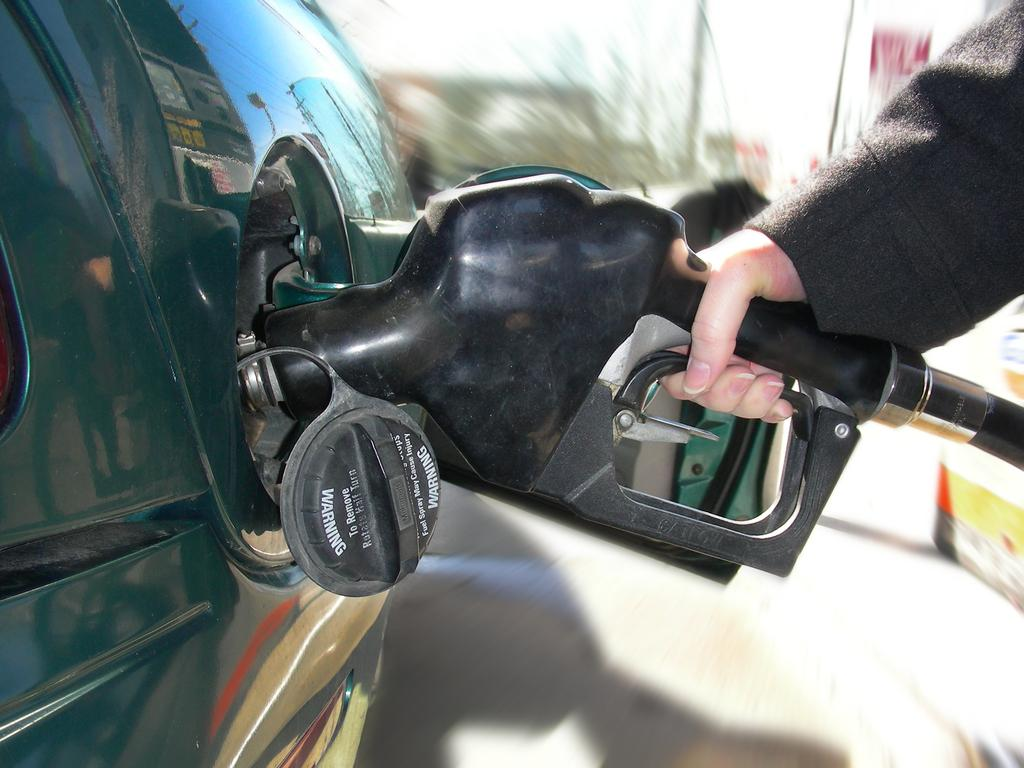What is the main subject in the foreground of the image? There is a person in the foreground of the image. What is the person doing in the image? The person is holding a petrol pump pipe and filling it in a car. What can be seen in the background of the image? There are trees, poles, the sky, and banners visible in the background of the image. What type of box is being used to transport the boat in the image? There is no boat or box present in the image; it features a person filling a petrol pump pipe in a car. What rule is being enforced by the person in the image? There is no indication of a rule being enforced in the image; the person is simply filling a petrol pump pipe in a car. 